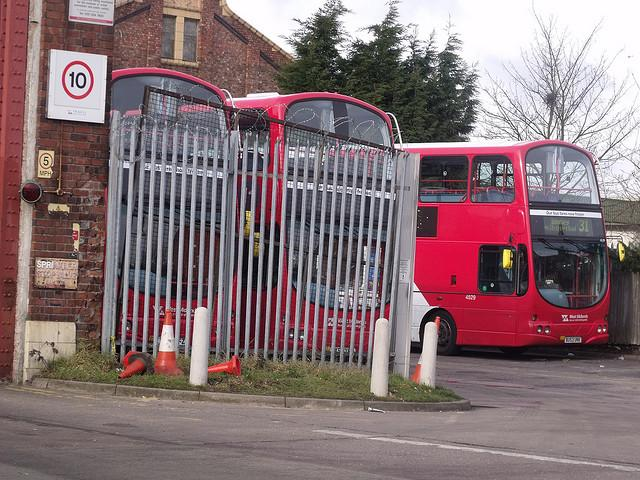Which side of the street do the busses seen here travel when driving forward? left 